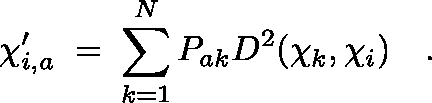<formula> <loc_0><loc_0><loc_500><loc_500>\chi _ { i , a } ^ { \prime } \, = \, \sum _ { k = 1 } ^ { N } P _ { a k } D ^ { 2 } ( \chi _ { k } , \chi _ { i } ) \quad .</formula> 